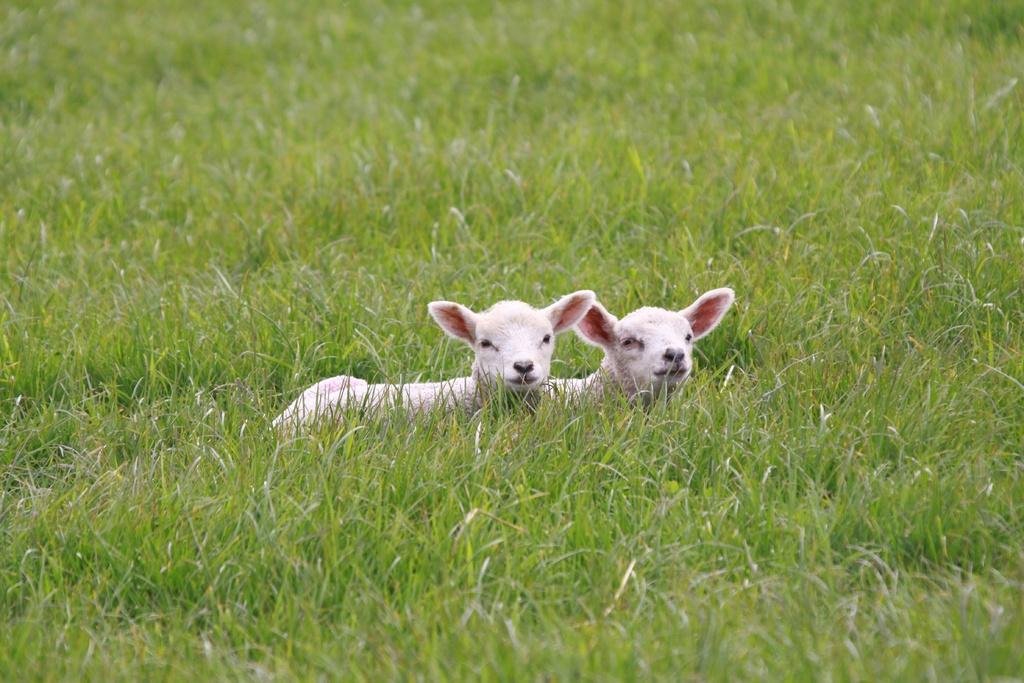Please provide a concise description of this image. In the picture we can see, full of grass plants in it, we can see two lamps which are white in color. 